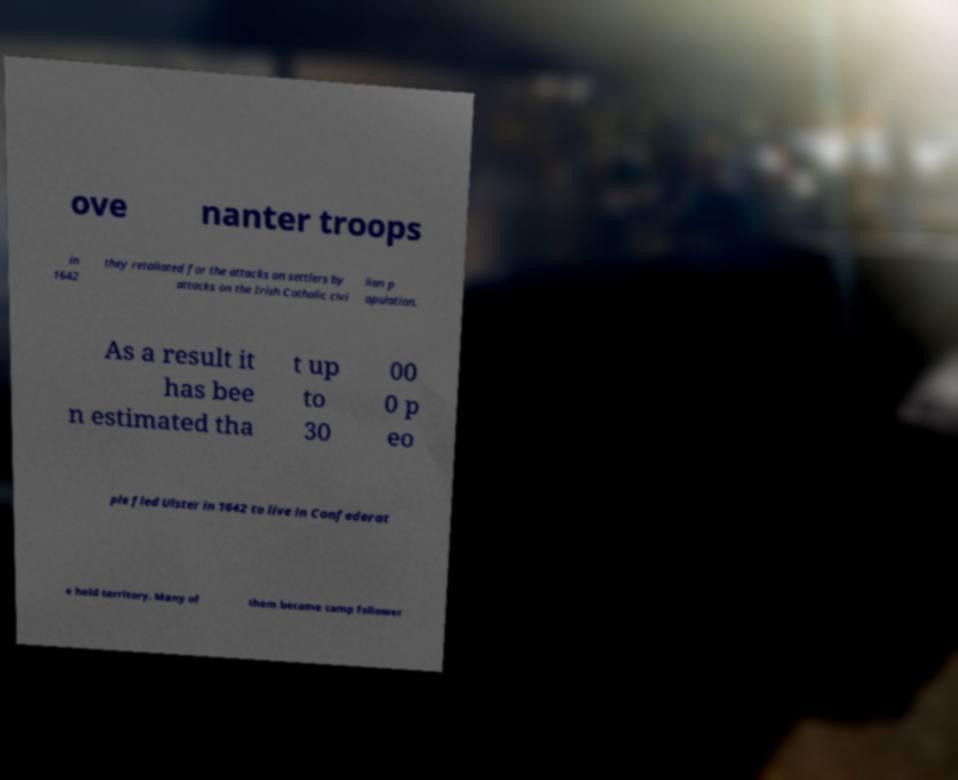What messages or text are displayed in this image? I need them in a readable, typed format. ove nanter troops in 1642 they retaliated for the attacks on settlers by attacks on the Irish Catholic civi lian p opulation. As a result it has bee n estimated tha t up to 30 00 0 p eo ple fled Ulster in 1642 to live in Confederat e held territory. Many of them became camp follower 